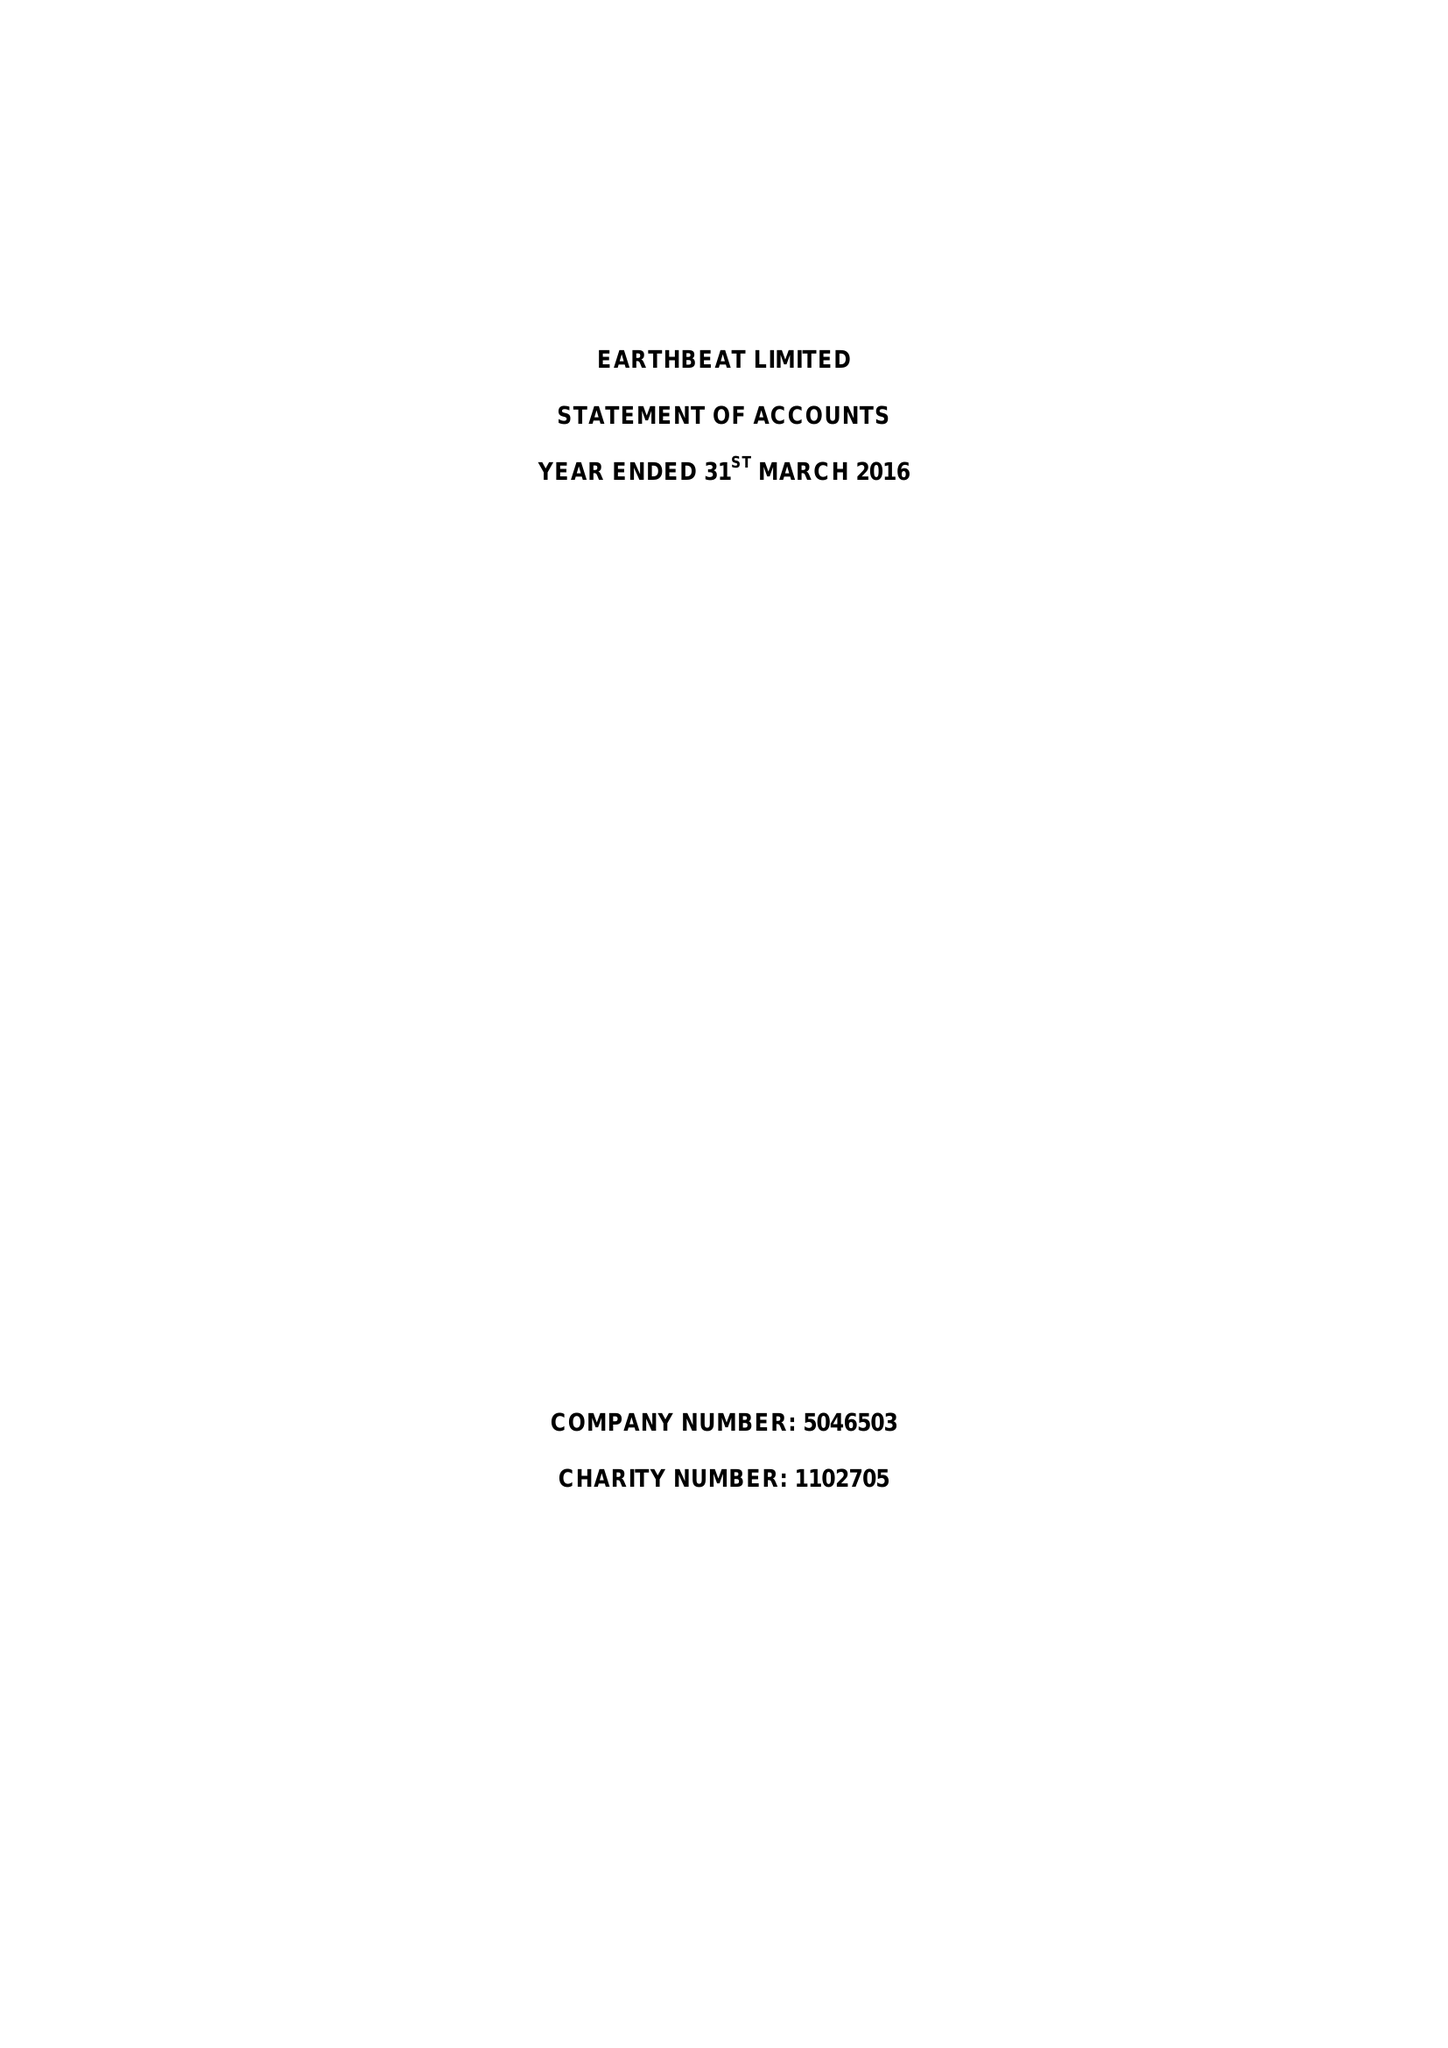What is the value for the income_annually_in_british_pounds?
Answer the question using a single word or phrase. 344001.00 